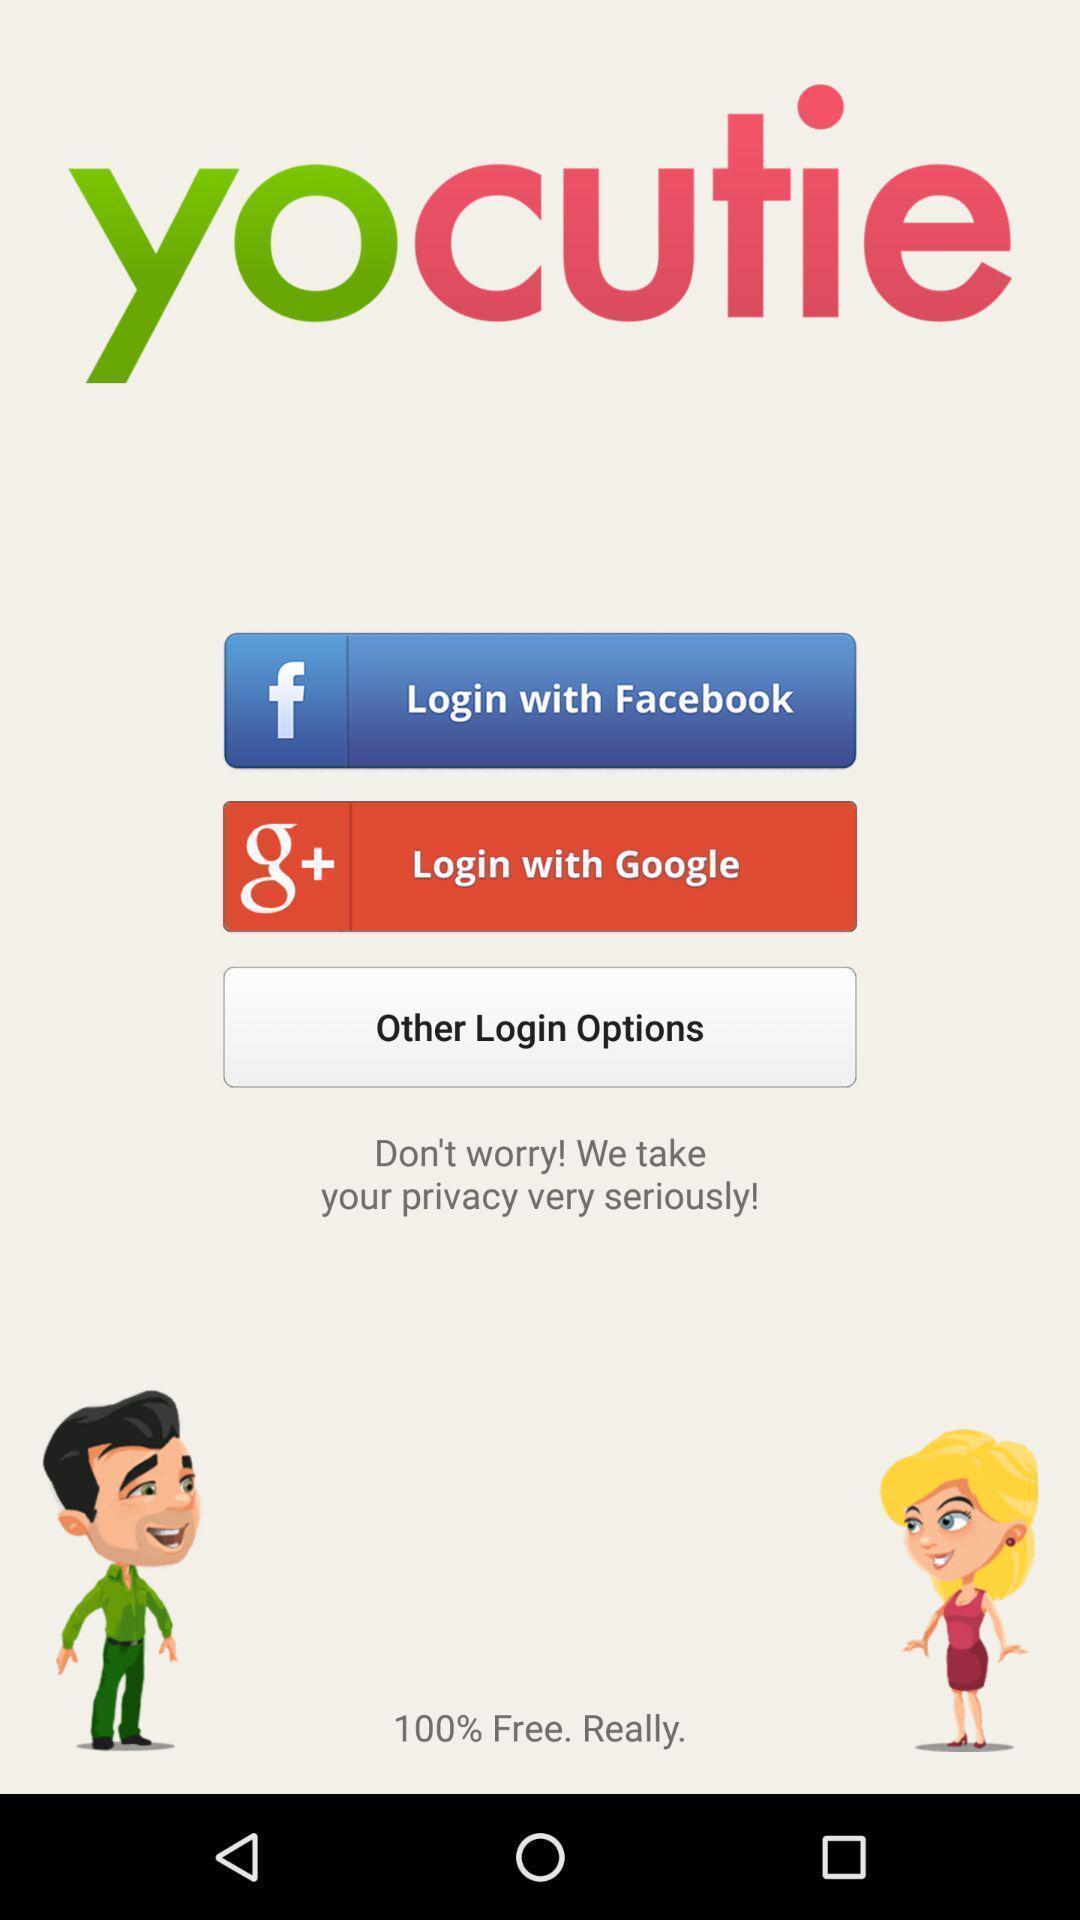Give me a summary of this screen capture. Welcome page of a social app. 